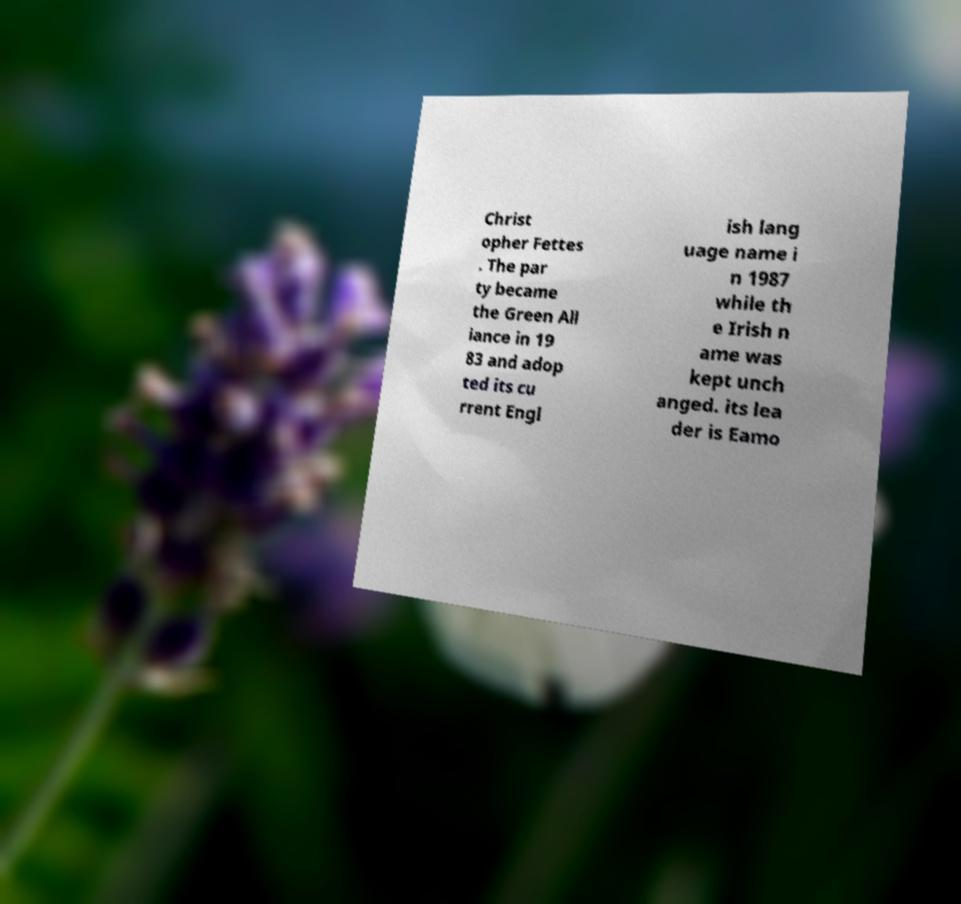Please identify and transcribe the text found in this image. Christ opher Fettes . The par ty became the Green All iance in 19 83 and adop ted its cu rrent Engl ish lang uage name i n 1987 while th e Irish n ame was kept unch anged. its lea der is Eamo 